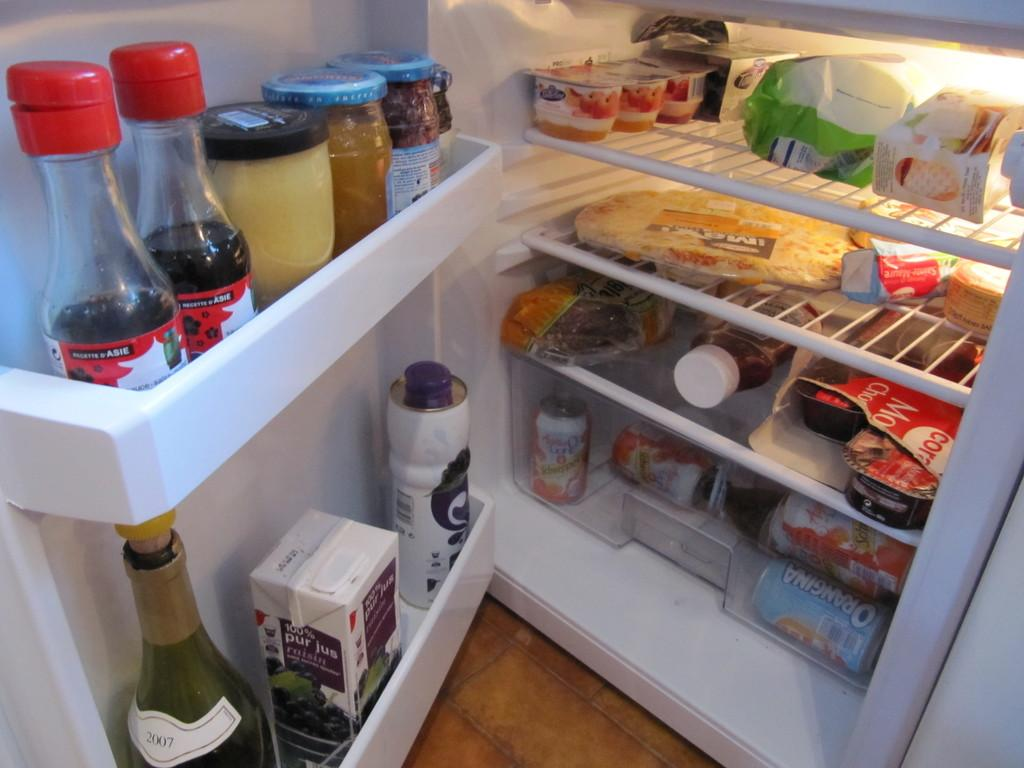What types of containers can be found in the refrigerator in the image? There are bottles, jars, beverage bottles, tins, and cups in the refrigerator. What food items are present in the refrigerator? There is butter and cakes in the refrigerator. What type of horn can be seen in the refrigerator? There is no horn present in the refrigerator; it contains bottles, jars, beverage bottles, tins, cups, butter, and cakes. 